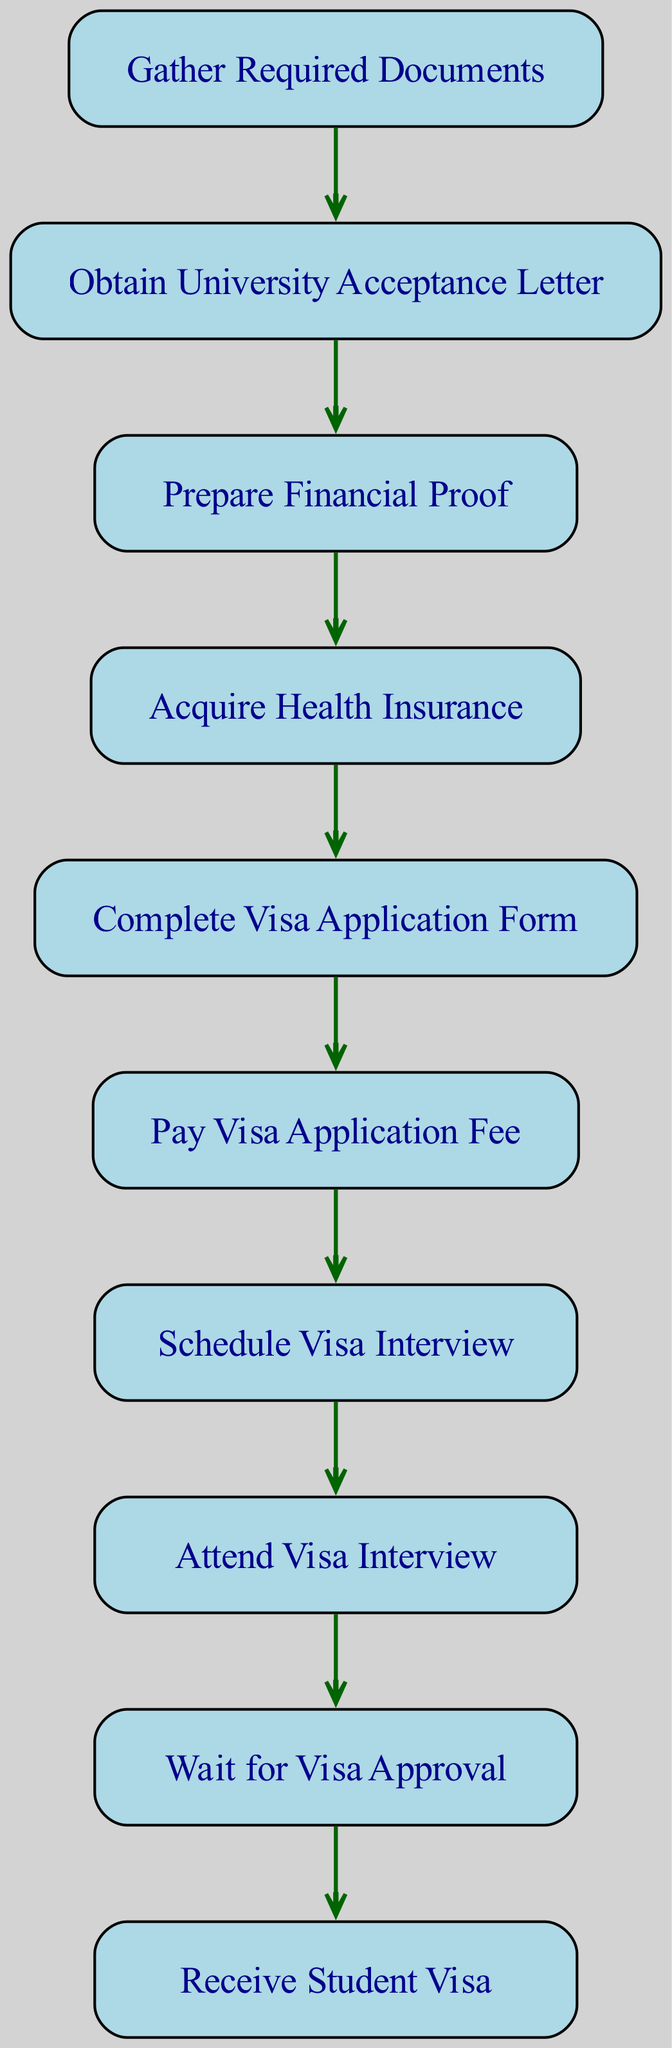What is the first step in applying for a student visa? The first step as indicated in the diagram is "Gather Required Documents." This node is the starting point of the directed graph, and no other node precedes it.
Answer: Gather Required Documents How many nodes are present in the diagram? To find the number of nodes, we can count all the unique steps listed in the diagram. There are 10 distinct nodes in total.
Answer: 10 Which step comes after "Complete Visa Application Form"? The next step after "Complete Visa Application Form" according to the edges in the diagram is "Pay Visa Application Fee." This follows directly from the connection between these two nodes.
Answer: Pay Visa Application Fee What do you need to do before attending the visa interview? Before attending the visa interview, you must first schedule the interview. This is represented by the directed edge from "Schedule Visa Interview" to "Attend Visa Interview."
Answer: Schedule Visa Interview What is the final outcome of the visa application process? The final outcome as shown in the diagram is represented by the node "Receive Student Visa." It comes after successfully waiting for the visa approval.
Answer: Receive Student Visa Which two steps are directly connected in the visa application process? There are many directly connected steps in the diagram. One example is "Health Insurance" and "Complete Visa Application Form," as there is a direct edge from the former to the latter.
Answer: Health Insurance and Complete Visa Application Form What is the relationship between "Obtain University Acceptance Letter" and "Prepare Financial Proof"? The relationship is sequential; you must first "Obtain University Acceptance Letter" before you can "Prepare Financial Proof," as indicated by the directed edge between these two nodes.
Answer: Sequential relationship How many edges connect the nodes in this graph? The total number of edges can be determined by counting the directed connections that represent the flow between the steps in the diagram. In total, there are 9 edges connecting the 10 nodes.
Answer: 9 What comes immediately before "Receive Student Visa"? Immediately before receiving the student visa, you must wait for the visa approval, as depicted by the directed edge leading to the final node in the sequence.
Answer: Wait for Visa Approval 